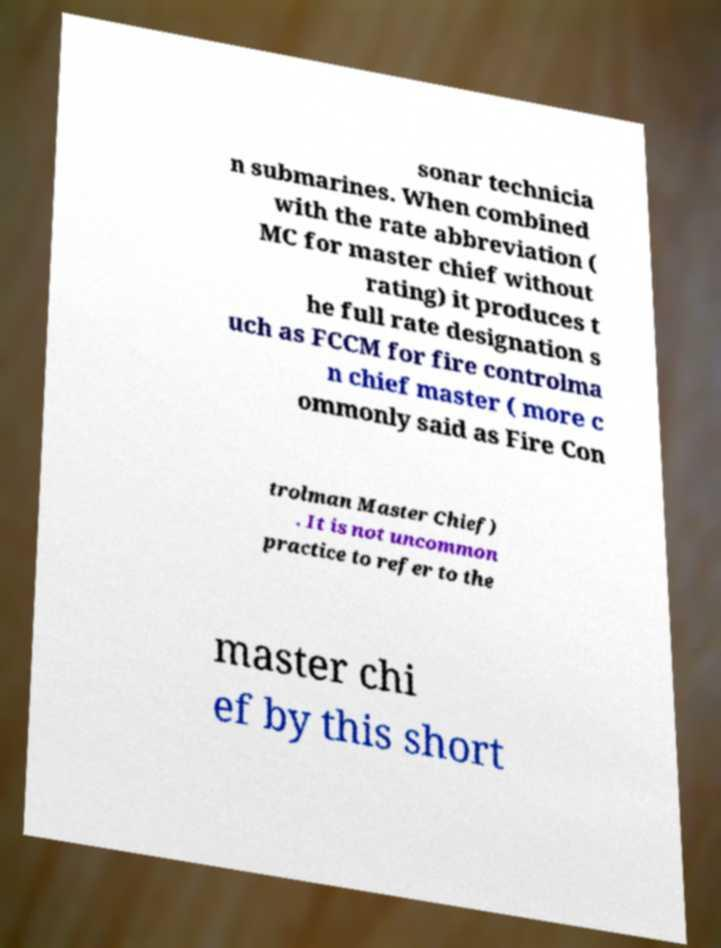Please identify and transcribe the text found in this image. sonar technicia n submarines. When combined with the rate abbreviation ( MC for master chief without rating) it produces t he full rate designation s uch as FCCM for fire controlma n chief master ( more c ommonly said as Fire Con trolman Master Chief) . It is not uncommon practice to refer to the master chi ef by this short 